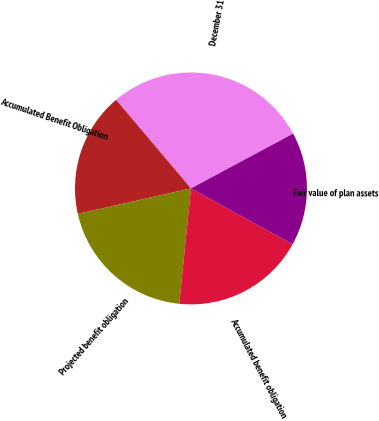Convert chart to OTSL. <chart><loc_0><loc_0><loc_500><loc_500><pie_chart><fcel>December 31<fcel>Accumulated Benefit Obligation<fcel>Projected benefit obligation<fcel>Accumulated benefit obligation<fcel>Fair value of plan assets<nl><fcel>28.33%<fcel>17.36%<fcel>19.86%<fcel>18.61%<fcel>15.83%<nl></chart> 